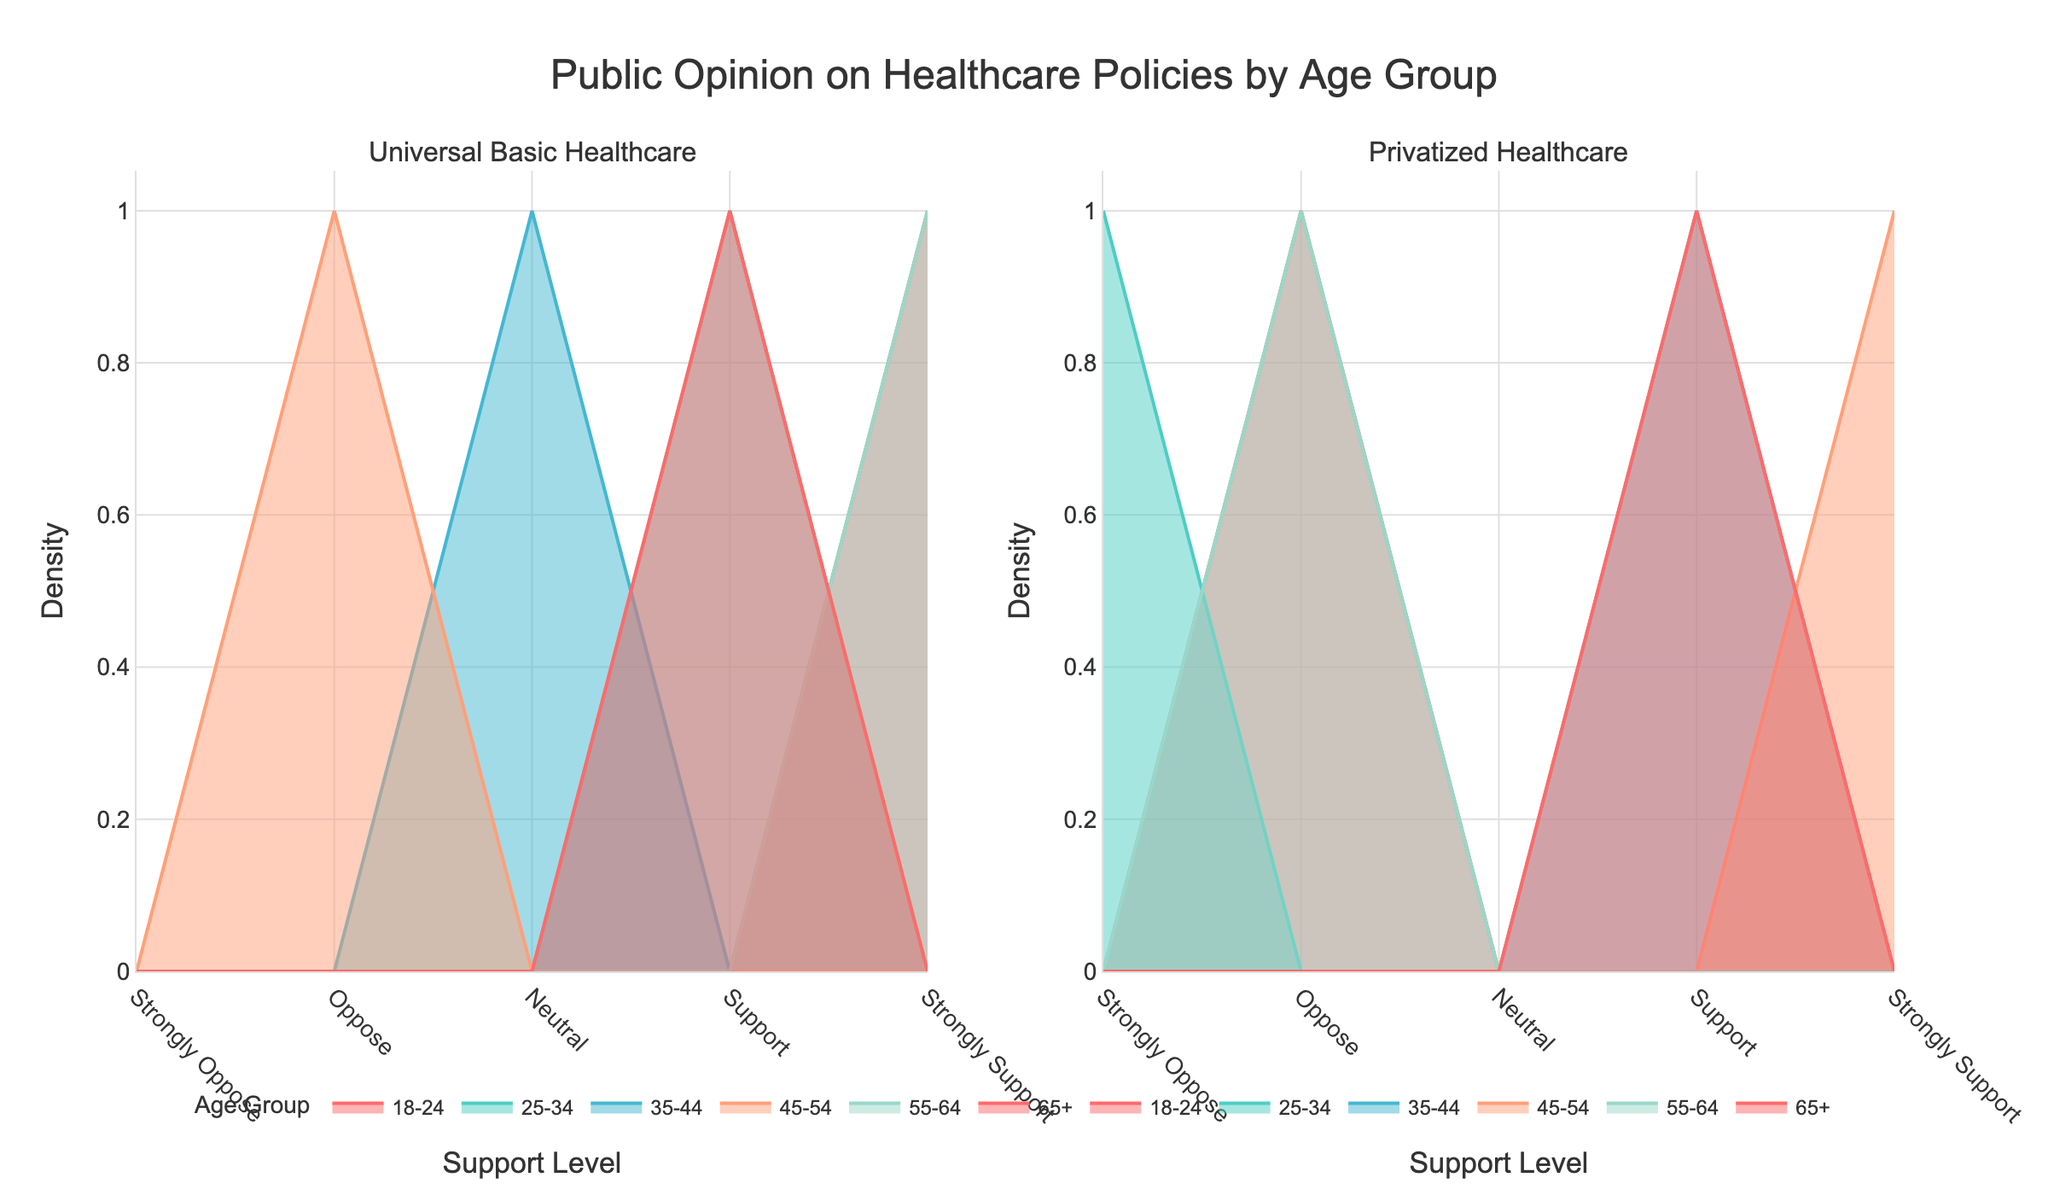What is the title of the figure? The title of the figure is displayed prominently at the top, indicating the overarching theme or subject of the plot.
Answer: Public Opinion on Healthcare Policies by Age Group How many subplots are present in the figure? The figure is divided into sections based on different data groups, making it clear how many distinct subplots there are. By counting the sections, one can determine the number.
Answer: 2 Which age group shows the highest density of 'Strongly Support' for Universal Basic Healthcare? By examining the subplot for Universal Basic Healthcare and locating the peak of the Strongly Support category, you can determine which age group has the highest density.
Answer: 55-64 For the Privatized Healthcare subplot, which support level has the least density among the 18-24 age group? In the subplot for Privatized Healthcare, identifying the values represented for each support level within the 18-24 age group will show which one has the smallest value.
Answer: Strongly Support Compare the density of the 'Support' level between the 25-34 age group in Universal Basic Healthcare and Privatized Healthcare. Which one is higher? By looking at the density values for the 'Support' level in both subplots and focusing on the 25-34 age group, you can compare the height of the lines to see which is higher.
Answer: Universal Basic Healthcare Is there any age group that shows a 'Neutral' support level in both healthcare policies? By identifying the line for each age group and looking at the 'Neutral' category within both subplots, you can see if any age group has data for both.
Answer: 35-44 How does the 65+ age group's support for Universal Basic Healthcare compare to their support for Privatized Healthcare? Comparing the density values of all support levels for the 65+ age group in both subplots, observe the differences in heights across the support levels.
Answer: Higher in Universal Basic Healthcare Which support level has the highest cumulative density for Universal Basic Healthcare when summed across all age groups? Summing up the densities for each age group at all support levels for Universal Basic Healthcare, you can find the level with the highest total density.
Answer: Strongly Support Which age group has the highest density of 'Oppose' for Privatized Healthcare? In the subplot for Privatized Healthcare, identifying and comparing the heights of the lines at the 'Oppose' level across age groups will reveal the highest one.
Answer: 18-24 Do any age groups show 'Strongly Oppose' for both healthcare policies? By examining the density plots for 'Strongly Oppose' across both subplots, you can determine if an age group has data points in this category in both plots.
Answer: No 